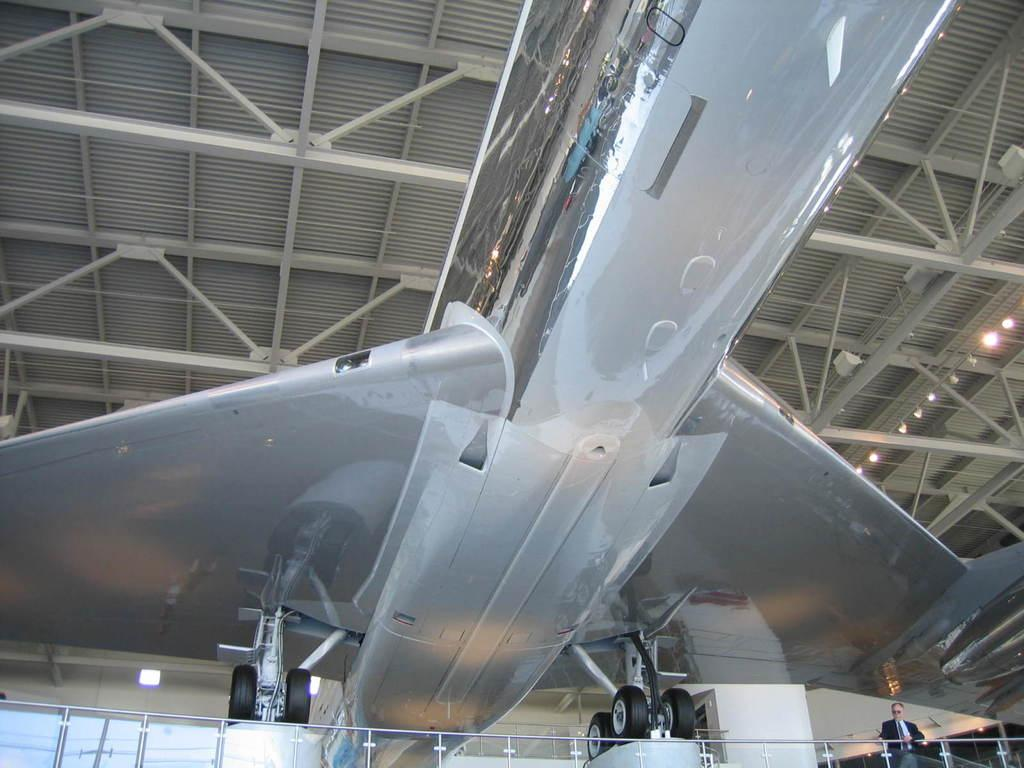What is the perspective of the image? The image shows a bottom view of an airplane. Can you describe any people or objects in the image? There is a person on the right side of the image. What can be seen in the background of the image? There is a roof visible in the background of the image. What type of canvas is the person using to paint the airplane in the image? There is no canvas or painting activity present in the image. 